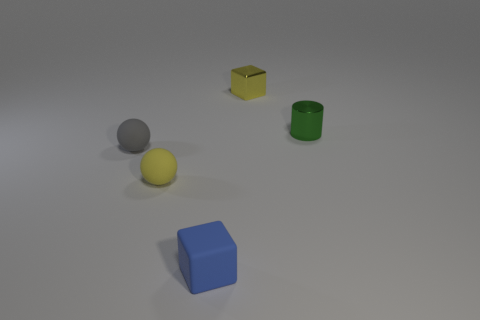What shapes and colors can be observed in this image? In the image, you can see a gray sphere, a yellow sphere, a green cylinder, a blue cube, and a small yellow cube. 